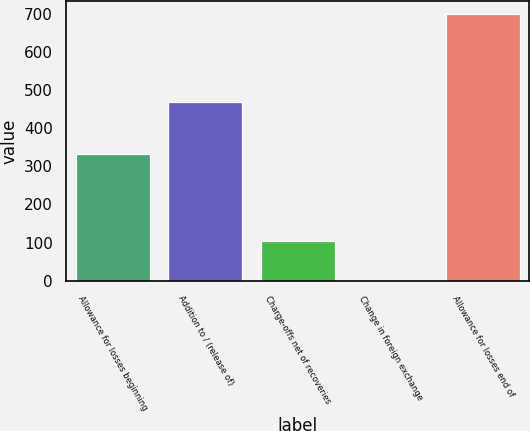<chart> <loc_0><loc_0><loc_500><loc_500><bar_chart><fcel>Allowance for losses beginning<fcel>Addition to / (release of)<fcel>Charge-offs net of recoveries<fcel>Change in foreign exchange<fcel>Allowance for losses end of<nl><fcel>332<fcel>468<fcel>105<fcel>3<fcel>698<nl></chart> 